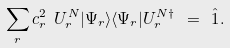Convert formula to latex. <formula><loc_0><loc_0><loc_500><loc_500>\sum _ { r } c _ { r } ^ { 2 } \ U _ { r } ^ { N } | \Psi _ { r } \rangle \langle \Psi _ { r } | U ^ { N \dagger } _ { r } \ = \ \hat { 1 } .</formula> 